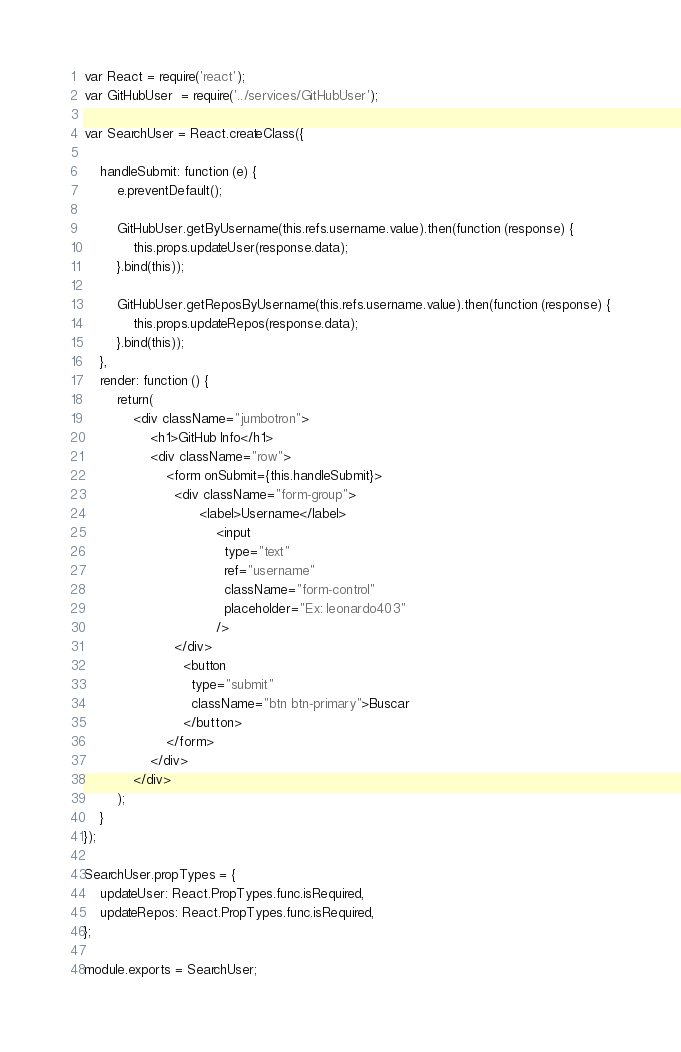Convert code to text. <code><loc_0><loc_0><loc_500><loc_500><_JavaScript_>var React = require('react');
var GitHubUser  = require('../services/GitHubUser');

var SearchUser = React.createClass({
	
	handleSubmit: function (e) {
		e.preventDefault();

		GitHubUser.getByUsername(this.refs.username.value).then(function (response) {
			this.props.updateUser(response.data);	  
		}.bind(this));

		GitHubUser.getReposByUsername(this.refs.username.value).then(function (response) {
			this.props.updateRepos(response.data);	  
		}.bind(this));	 
	},
	render: function () {
		return(
			<div className="jumbotron">
				<h1>GitHub Info</h1>
				<div className="row">
					<form onSubmit={this.handleSubmit}>
					  <div className="form-group">
							<label>Username</label>
								<input
								  type="text"
								  ref="username"
								  className="form-control"
							 	  placeholder="Ex: leonardo403"		
								/>
					  </div>
						<button 
						  type="submit"
						  className="btn btn-primary">Buscar
					  	</button>
					</form>
				</div>
			</div>
		); 
	}
});

SearchUser.propTypes = {
	updateUser: React.PropTypes.func.isRequired,
	updateRepos: React.PropTypes.func.isRequired,
};

module.exports = SearchUser;</code> 